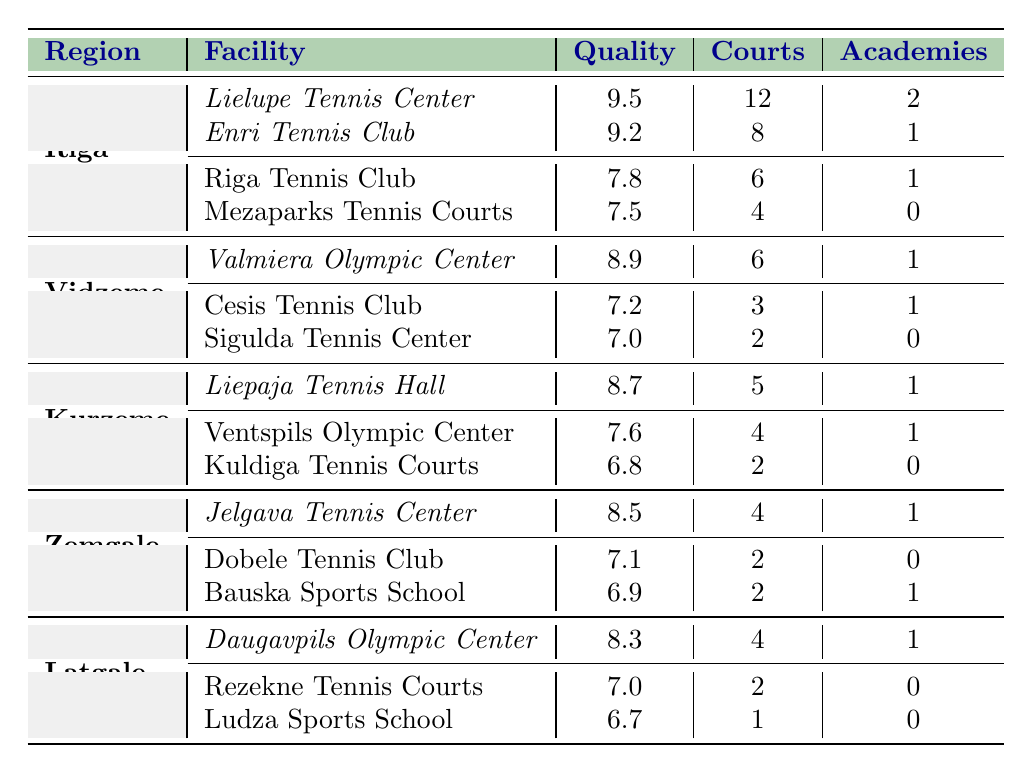What is the highest quality rating among tennis facilities in the Riga Region? The highest quality rating in the Riga Region is found at the Lielupe Tennis Center, which has a rating of 9.5.
Answer: 9.5 How many total courts are available at the premium facilities in Kurzeme Region? The premium facility in Kurzeme Region is the Liepaja Tennis Hall, which has 5 courts. Therefore, the total number of courts at premium facilities in Kurzeme is 5.
Answer: 5 Which region has the lowest quality rating for its standard facilities? The standard facilities in Kurzeme have the lowest quality rating: Kuldiga Tennis Courts with a 6.8.
Answer: Kurzeme Region How many academies are associated with the Jelgava Tennis Center? The Jelgava Tennis Center, located in the Zemgale Region, has 1 associated academy.
Answer: 1 What is the average quality rating of standard facilities across all regions? The standard facilities have quality ratings of 7.8 (Riga Tennis Club), 7.5 (Mezaparks Tennis Courts), 7.2 (Cesis Tennis Club), 7.0 (Sigulda Tennis Center), 7.6 (Ventspils Olympic Center), 6.8 (Kuldiga Tennis Courts), 7.1 (Dobele Tennis Club), 6.9 (Bauska Sports School), 7.0 (Rezekne Tennis Courts), and 6.7 (Ludza Sports School). The sum is 7.8 + 7.5 + 7.2 + 7.0 + 7.6 + 6.8 + 7.1 + 6.9 + 7.0 + 6.7 = 75.7, and there are 10 facilities, so the average is 75.7 / 10 = 7.57.
Answer: 7.57 Are there any standard facilities in Vidzeme Region with no associated academies? Yes, the Sigulda Tennis Center has no associated academies, thus confirming that there are standard facilities in Vidzeme with no academies.
Answer: Yes In which region can you find the facility with the highest quality rating, and what is that rating? The highest quality rating is in the Riga Region at the Lielupe Tennis Center, which has a rating of 9.5.
Answer: Riga Region, 9.5 What is the total number of courts across all premium facilities in Latvia? The total number of courts in premium facilities is: 12 (Lielupe) + 8 (Enri) + 6 (Valmiera) + 5 (Liepaja) + 4 (Jelgava) + 4 (Daugavpils) = 39 courts.
Answer: 39 Which region has the most facilities listed in the table? The Riga Region has the most facilities listed, totaling 4 in number (2 premium and 2 standard).
Answer: Riga Region How does the quality rating of the Daugavpils Olympic Center compare to that of the Ventspils Olympic Center? The Daugavpils Olympic Center has a quality rating of 8.3, while the Ventspils Olympic Center has a rating of 7.6, making Daugavpils higher.
Answer: Daugavpils is higher 